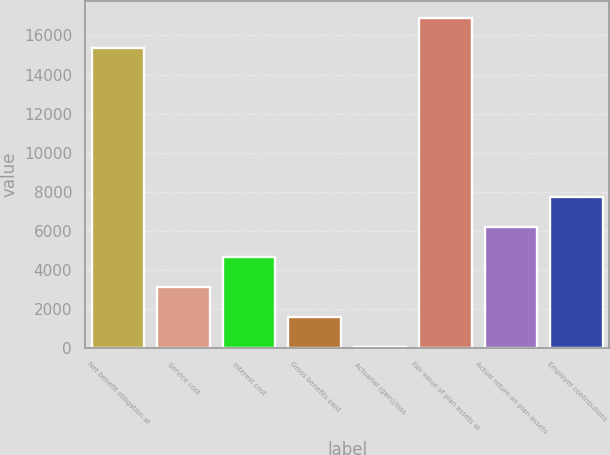<chart> <loc_0><loc_0><loc_500><loc_500><bar_chart><fcel>Net benefit obligation at<fcel>Service cost<fcel>Interest cost<fcel>Gross benefits paid<fcel>Actuarial (gain)/loss<fcel>Fair value of plan assets at<fcel>Actual return on plan assets<fcel>Employer contributions<nl><fcel>15363<fcel>3118<fcel>4650<fcel>1586<fcel>54<fcel>16895<fcel>6182<fcel>7714<nl></chart> 